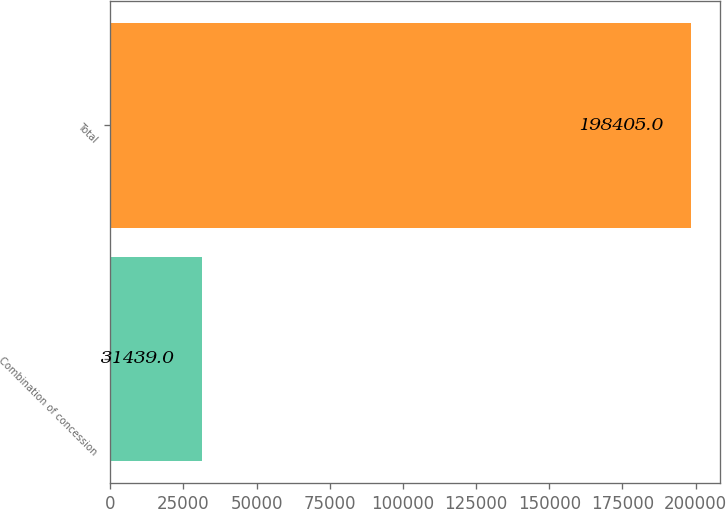Convert chart to OTSL. <chart><loc_0><loc_0><loc_500><loc_500><bar_chart><fcel>Combination of concession<fcel>Total<nl><fcel>31439<fcel>198405<nl></chart> 